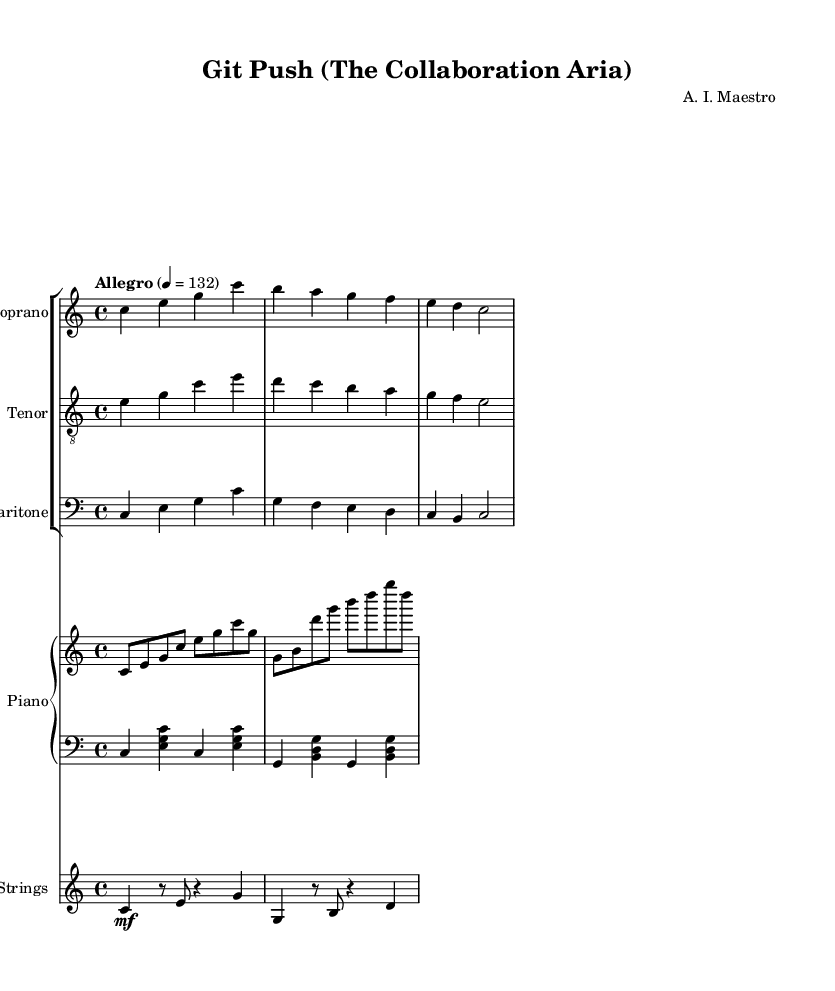What is the key signature of this music? The key signature is indicated at the beginning of the piece and shows no sharps or flats. This means it is in the key of C major.
Answer: C major What is the time signature of this music? The time signature appears at the beginning of the score, which is shown as 4/4. This means there are four beats in each measure, and the quarter note gets one beat.
Answer: 4/4 What is the tempo marking for this piece? The tempo marking is found at the beginning, stating "Allegro" and a metronome marking of 132 per minute. This indicates a lively and brisk speed for the performance.
Answer: Allegro, 132 Which voice is performing the highest part? The soprano voice is notated on the treble clef and covers the highest range of notes among the three vocal parts, thus performs the highest part.
Answer: Soprano How many measures are there in the soprano part provided? A careful count of the measures in the soprano part shows there are a total of three measures.
Answer: Three What is the lyric theme of the chorus in this opera? The lyrics of the chorus emphasize collaboration, knowledge sharing, and innovation in software development, reflecting themes of open-source culture.
Answer: Collaboration Which instrument plays in the bass clef? The bass clef is used for the baritone voice, which typically lies in the lower vocal range, and is also used for the piano left hand part shown below it.
Answer: Baritone, piano left hand 